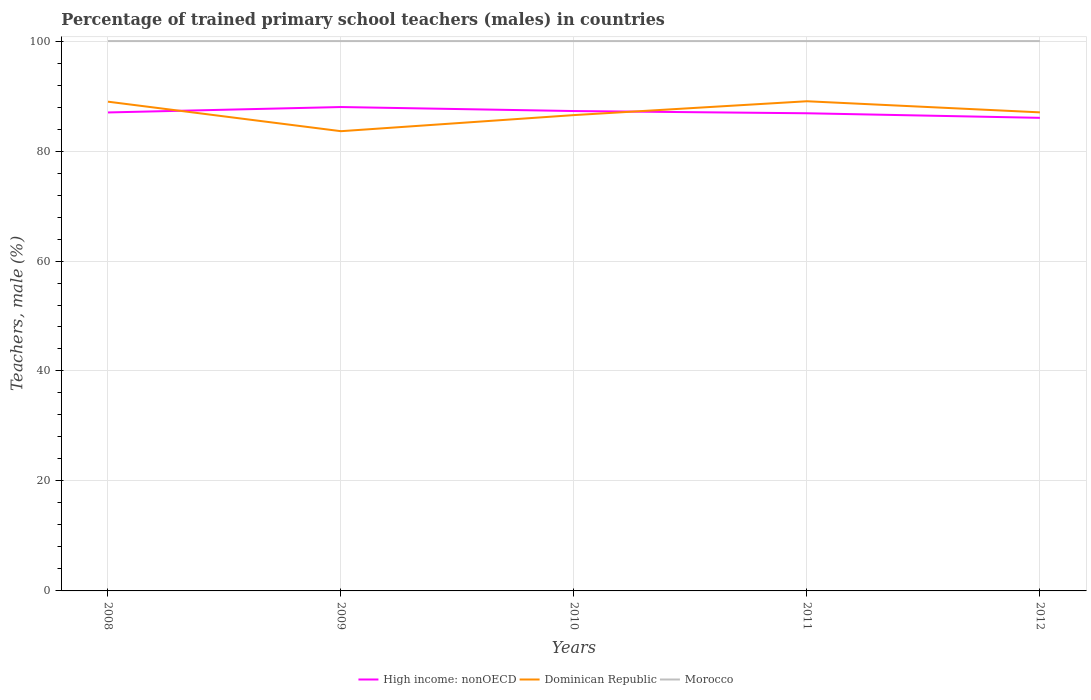Does the line corresponding to Morocco intersect with the line corresponding to Dominican Republic?
Ensure brevity in your answer.  No. What is the difference between the highest and the second highest percentage of trained primary school teachers (males) in Morocco?
Provide a succinct answer. 0. What is the difference between two consecutive major ticks on the Y-axis?
Offer a very short reply. 20. Where does the legend appear in the graph?
Your response must be concise. Bottom center. What is the title of the graph?
Keep it short and to the point. Percentage of trained primary school teachers (males) in countries. Does "Kenya" appear as one of the legend labels in the graph?
Keep it short and to the point. No. What is the label or title of the Y-axis?
Offer a terse response. Teachers, male (%). What is the Teachers, male (%) in High income: nonOECD in 2008?
Ensure brevity in your answer.  87.02. What is the Teachers, male (%) of Dominican Republic in 2008?
Give a very brief answer. 88.98. What is the Teachers, male (%) of Morocco in 2008?
Provide a succinct answer. 100. What is the Teachers, male (%) in High income: nonOECD in 2009?
Your answer should be compact. 88.01. What is the Teachers, male (%) of Dominican Republic in 2009?
Give a very brief answer. 83.61. What is the Teachers, male (%) in Morocco in 2009?
Provide a succinct answer. 100. What is the Teachers, male (%) in High income: nonOECD in 2010?
Your answer should be compact. 87.27. What is the Teachers, male (%) of Dominican Republic in 2010?
Keep it short and to the point. 86.54. What is the Teachers, male (%) of Morocco in 2010?
Your answer should be compact. 100. What is the Teachers, male (%) in High income: nonOECD in 2011?
Make the answer very short. 86.87. What is the Teachers, male (%) in Dominican Republic in 2011?
Make the answer very short. 89.06. What is the Teachers, male (%) of Morocco in 2011?
Keep it short and to the point. 100. What is the Teachers, male (%) in High income: nonOECD in 2012?
Give a very brief answer. 86.04. What is the Teachers, male (%) in Dominican Republic in 2012?
Provide a short and direct response. 87.04. Across all years, what is the maximum Teachers, male (%) in High income: nonOECD?
Make the answer very short. 88.01. Across all years, what is the maximum Teachers, male (%) in Dominican Republic?
Ensure brevity in your answer.  89.06. Across all years, what is the minimum Teachers, male (%) of High income: nonOECD?
Ensure brevity in your answer.  86.04. Across all years, what is the minimum Teachers, male (%) of Dominican Republic?
Your answer should be very brief. 83.61. What is the total Teachers, male (%) of High income: nonOECD in the graph?
Provide a short and direct response. 435.21. What is the total Teachers, male (%) in Dominican Republic in the graph?
Your answer should be compact. 435.22. What is the total Teachers, male (%) of Morocco in the graph?
Your response must be concise. 500. What is the difference between the Teachers, male (%) of High income: nonOECD in 2008 and that in 2009?
Ensure brevity in your answer.  -0.99. What is the difference between the Teachers, male (%) of Dominican Republic in 2008 and that in 2009?
Give a very brief answer. 5.37. What is the difference between the Teachers, male (%) of Morocco in 2008 and that in 2009?
Offer a very short reply. 0. What is the difference between the Teachers, male (%) of High income: nonOECD in 2008 and that in 2010?
Offer a very short reply. -0.25. What is the difference between the Teachers, male (%) in Dominican Republic in 2008 and that in 2010?
Keep it short and to the point. 2.44. What is the difference between the Teachers, male (%) of High income: nonOECD in 2008 and that in 2011?
Give a very brief answer. 0.15. What is the difference between the Teachers, male (%) in Dominican Republic in 2008 and that in 2011?
Keep it short and to the point. -0.08. What is the difference between the Teachers, male (%) of Morocco in 2008 and that in 2011?
Provide a succinct answer. 0. What is the difference between the Teachers, male (%) of High income: nonOECD in 2008 and that in 2012?
Make the answer very short. 0.98. What is the difference between the Teachers, male (%) in Dominican Republic in 2008 and that in 2012?
Your response must be concise. 1.94. What is the difference between the Teachers, male (%) in Morocco in 2008 and that in 2012?
Provide a short and direct response. 0. What is the difference between the Teachers, male (%) of High income: nonOECD in 2009 and that in 2010?
Offer a terse response. 0.73. What is the difference between the Teachers, male (%) of Dominican Republic in 2009 and that in 2010?
Make the answer very short. -2.93. What is the difference between the Teachers, male (%) of High income: nonOECD in 2009 and that in 2011?
Give a very brief answer. 1.13. What is the difference between the Teachers, male (%) in Dominican Republic in 2009 and that in 2011?
Your answer should be compact. -5.45. What is the difference between the Teachers, male (%) in Morocco in 2009 and that in 2011?
Give a very brief answer. 0. What is the difference between the Teachers, male (%) in High income: nonOECD in 2009 and that in 2012?
Your response must be concise. 1.97. What is the difference between the Teachers, male (%) of Dominican Republic in 2009 and that in 2012?
Give a very brief answer. -3.43. What is the difference between the Teachers, male (%) in Morocco in 2009 and that in 2012?
Provide a short and direct response. 0. What is the difference between the Teachers, male (%) in High income: nonOECD in 2010 and that in 2011?
Your answer should be very brief. 0.4. What is the difference between the Teachers, male (%) in Dominican Republic in 2010 and that in 2011?
Provide a short and direct response. -2.52. What is the difference between the Teachers, male (%) of Morocco in 2010 and that in 2011?
Your answer should be compact. 0. What is the difference between the Teachers, male (%) in High income: nonOECD in 2010 and that in 2012?
Offer a very short reply. 1.23. What is the difference between the Teachers, male (%) of Dominican Republic in 2010 and that in 2012?
Your answer should be very brief. -0.5. What is the difference between the Teachers, male (%) in Morocco in 2010 and that in 2012?
Your answer should be compact. 0. What is the difference between the Teachers, male (%) of High income: nonOECD in 2011 and that in 2012?
Your answer should be very brief. 0.83. What is the difference between the Teachers, male (%) in Dominican Republic in 2011 and that in 2012?
Your answer should be compact. 2.02. What is the difference between the Teachers, male (%) in High income: nonOECD in 2008 and the Teachers, male (%) in Dominican Republic in 2009?
Provide a succinct answer. 3.41. What is the difference between the Teachers, male (%) in High income: nonOECD in 2008 and the Teachers, male (%) in Morocco in 2009?
Provide a short and direct response. -12.98. What is the difference between the Teachers, male (%) in Dominican Republic in 2008 and the Teachers, male (%) in Morocco in 2009?
Your answer should be compact. -11.02. What is the difference between the Teachers, male (%) of High income: nonOECD in 2008 and the Teachers, male (%) of Dominican Republic in 2010?
Offer a very short reply. 0.48. What is the difference between the Teachers, male (%) of High income: nonOECD in 2008 and the Teachers, male (%) of Morocco in 2010?
Make the answer very short. -12.98. What is the difference between the Teachers, male (%) of Dominican Republic in 2008 and the Teachers, male (%) of Morocco in 2010?
Your response must be concise. -11.02. What is the difference between the Teachers, male (%) in High income: nonOECD in 2008 and the Teachers, male (%) in Dominican Republic in 2011?
Your answer should be compact. -2.04. What is the difference between the Teachers, male (%) in High income: nonOECD in 2008 and the Teachers, male (%) in Morocco in 2011?
Keep it short and to the point. -12.98. What is the difference between the Teachers, male (%) of Dominican Republic in 2008 and the Teachers, male (%) of Morocco in 2011?
Provide a succinct answer. -11.02. What is the difference between the Teachers, male (%) of High income: nonOECD in 2008 and the Teachers, male (%) of Dominican Republic in 2012?
Make the answer very short. -0.02. What is the difference between the Teachers, male (%) of High income: nonOECD in 2008 and the Teachers, male (%) of Morocco in 2012?
Ensure brevity in your answer.  -12.98. What is the difference between the Teachers, male (%) of Dominican Republic in 2008 and the Teachers, male (%) of Morocco in 2012?
Your response must be concise. -11.02. What is the difference between the Teachers, male (%) of High income: nonOECD in 2009 and the Teachers, male (%) of Dominican Republic in 2010?
Keep it short and to the point. 1.47. What is the difference between the Teachers, male (%) in High income: nonOECD in 2009 and the Teachers, male (%) in Morocco in 2010?
Your response must be concise. -11.99. What is the difference between the Teachers, male (%) of Dominican Republic in 2009 and the Teachers, male (%) of Morocco in 2010?
Provide a short and direct response. -16.39. What is the difference between the Teachers, male (%) of High income: nonOECD in 2009 and the Teachers, male (%) of Dominican Republic in 2011?
Your answer should be compact. -1.05. What is the difference between the Teachers, male (%) of High income: nonOECD in 2009 and the Teachers, male (%) of Morocco in 2011?
Your response must be concise. -11.99. What is the difference between the Teachers, male (%) in Dominican Republic in 2009 and the Teachers, male (%) in Morocco in 2011?
Keep it short and to the point. -16.39. What is the difference between the Teachers, male (%) in High income: nonOECD in 2009 and the Teachers, male (%) in Dominican Republic in 2012?
Your response must be concise. 0.97. What is the difference between the Teachers, male (%) of High income: nonOECD in 2009 and the Teachers, male (%) of Morocco in 2012?
Ensure brevity in your answer.  -11.99. What is the difference between the Teachers, male (%) in Dominican Republic in 2009 and the Teachers, male (%) in Morocco in 2012?
Offer a very short reply. -16.39. What is the difference between the Teachers, male (%) in High income: nonOECD in 2010 and the Teachers, male (%) in Dominican Republic in 2011?
Make the answer very short. -1.78. What is the difference between the Teachers, male (%) in High income: nonOECD in 2010 and the Teachers, male (%) in Morocco in 2011?
Offer a terse response. -12.73. What is the difference between the Teachers, male (%) of Dominican Republic in 2010 and the Teachers, male (%) of Morocco in 2011?
Your answer should be compact. -13.46. What is the difference between the Teachers, male (%) in High income: nonOECD in 2010 and the Teachers, male (%) in Dominican Republic in 2012?
Make the answer very short. 0.24. What is the difference between the Teachers, male (%) in High income: nonOECD in 2010 and the Teachers, male (%) in Morocco in 2012?
Keep it short and to the point. -12.73. What is the difference between the Teachers, male (%) of Dominican Republic in 2010 and the Teachers, male (%) of Morocco in 2012?
Make the answer very short. -13.46. What is the difference between the Teachers, male (%) in High income: nonOECD in 2011 and the Teachers, male (%) in Dominican Republic in 2012?
Your answer should be very brief. -0.16. What is the difference between the Teachers, male (%) in High income: nonOECD in 2011 and the Teachers, male (%) in Morocco in 2012?
Ensure brevity in your answer.  -13.13. What is the difference between the Teachers, male (%) of Dominican Republic in 2011 and the Teachers, male (%) of Morocco in 2012?
Keep it short and to the point. -10.94. What is the average Teachers, male (%) of High income: nonOECD per year?
Provide a succinct answer. 87.04. What is the average Teachers, male (%) of Dominican Republic per year?
Offer a very short reply. 87.04. In the year 2008, what is the difference between the Teachers, male (%) in High income: nonOECD and Teachers, male (%) in Dominican Republic?
Provide a short and direct response. -1.96. In the year 2008, what is the difference between the Teachers, male (%) of High income: nonOECD and Teachers, male (%) of Morocco?
Offer a terse response. -12.98. In the year 2008, what is the difference between the Teachers, male (%) in Dominican Republic and Teachers, male (%) in Morocco?
Provide a short and direct response. -11.02. In the year 2009, what is the difference between the Teachers, male (%) of High income: nonOECD and Teachers, male (%) of Dominican Republic?
Your answer should be compact. 4.39. In the year 2009, what is the difference between the Teachers, male (%) in High income: nonOECD and Teachers, male (%) in Morocco?
Your response must be concise. -11.99. In the year 2009, what is the difference between the Teachers, male (%) of Dominican Republic and Teachers, male (%) of Morocco?
Ensure brevity in your answer.  -16.39. In the year 2010, what is the difference between the Teachers, male (%) in High income: nonOECD and Teachers, male (%) in Dominican Republic?
Your answer should be compact. 0.73. In the year 2010, what is the difference between the Teachers, male (%) in High income: nonOECD and Teachers, male (%) in Morocco?
Your response must be concise. -12.73. In the year 2010, what is the difference between the Teachers, male (%) in Dominican Republic and Teachers, male (%) in Morocco?
Offer a very short reply. -13.46. In the year 2011, what is the difference between the Teachers, male (%) in High income: nonOECD and Teachers, male (%) in Dominican Republic?
Make the answer very short. -2.18. In the year 2011, what is the difference between the Teachers, male (%) of High income: nonOECD and Teachers, male (%) of Morocco?
Offer a terse response. -13.13. In the year 2011, what is the difference between the Teachers, male (%) of Dominican Republic and Teachers, male (%) of Morocco?
Your answer should be very brief. -10.94. In the year 2012, what is the difference between the Teachers, male (%) in High income: nonOECD and Teachers, male (%) in Dominican Republic?
Your answer should be compact. -1. In the year 2012, what is the difference between the Teachers, male (%) in High income: nonOECD and Teachers, male (%) in Morocco?
Give a very brief answer. -13.96. In the year 2012, what is the difference between the Teachers, male (%) in Dominican Republic and Teachers, male (%) in Morocco?
Keep it short and to the point. -12.96. What is the ratio of the Teachers, male (%) of Dominican Republic in 2008 to that in 2009?
Offer a terse response. 1.06. What is the ratio of the Teachers, male (%) of High income: nonOECD in 2008 to that in 2010?
Ensure brevity in your answer.  1. What is the ratio of the Teachers, male (%) in Dominican Republic in 2008 to that in 2010?
Your response must be concise. 1.03. What is the ratio of the Teachers, male (%) of Morocco in 2008 to that in 2010?
Your answer should be very brief. 1. What is the ratio of the Teachers, male (%) in Dominican Republic in 2008 to that in 2011?
Offer a very short reply. 1. What is the ratio of the Teachers, male (%) of Morocco in 2008 to that in 2011?
Provide a succinct answer. 1. What is the ratio of the Teachers, male (%) in High income: nonOECD in 2008 to that in 2012?
Make the answer very short. 1.01. What is the ratio of the Teachers, male (%) in Dominican Republic in 2008 to that in 2012?
Your answer should be compact. 1.02. What is the ratio of the Teachers, male (%) of High income: nonOECD in 2009 to that in 2010?
Your response must be concise. 1.01. What is the ratio of the Teachers, male (%) of Dominican Republic in 2009 to that in 2010?
Provide a short and direct response. 0.97. What is the ratio of the Teachers, male (%) of Dominican Republic in 2009 to that in 2011?
Offer a terse response. 0.94. What is the ratio of the Teachers, male (%) in Morocco in 2009 to that in 2011?
Your answer should be very brief. 1. What is the ratio of the Teachers, male (%) in High income: nonOECD in 2009 to that in 2012?
Ensure brevity in your answer.  1.02. What is the ratio of the Teachers, male (%) in Dominican Republic in 2009 to that in 2012?
Offer a terse response. 0.96. What is the ratio of the Teachers, male (%) in Morocco in 2009 to that in 2012?
Provide a short and direct response. 1. What is the ratio of the Teachers, male (%) of High income: nonOECD in 2010 to that in 2011?
Make the answer very short. 1. What is the ratio of the Teachers, male (%) of Dominican Republic in 2010 to that in 2011?
Provide a short and direct response. 0.97. What is the ratio of the Teachers, male (%) in High income: nonOECD in 2010 to that in 2012?
Give a very brief answer. 1.01. What is the ratio of the Teachers, male (%) in Morocco in 2010 to that in 2012?
Your response must be concise. 1. What is the ratio of the Teachers, male (%) of High income: nonOECD in 2011 to that in 2012?
Provide a short and direct response. 1.01. What is the ratio of the Teachers, male (%) in Dominican Republic in 2011 to that in 2012?
Give a very brief answer. 1.02. What is the ratio of the Teachers, male (%) in Morocco in 2011 to that in 2012?
Keep it short and to the point. 1. What is the difference between the highest and the second highest Teachers, male (%) of High income: nonOECD?
Your answer should be compact. 0.73. What is the difference between the highest and the second highest Teachers, male (%) of Dominican Republic?
Keep it short and to the point. 0.08. What is the difference between the highest and the second highest Teachers, male (%) in Morocco?
Your response must be concise. 0. What is the difference between the highest and the lowest Teachers, male (%) of High income: nonOECD?
Your answer should be compact. 1.97. What is the difference between the highest and the lowest Teachers, male (%) in Dominican Republic?
Keep it short and to the point. 5.45. 